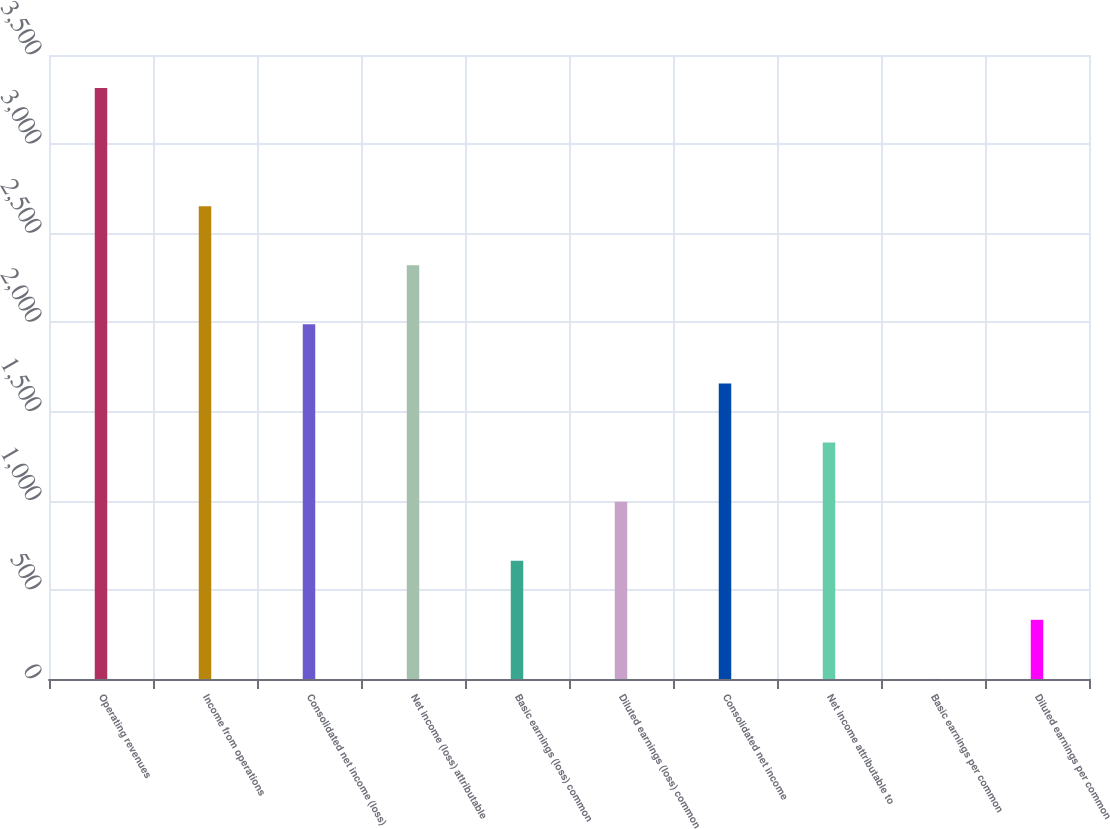Convert chart. <chart><loc_0><loc_0><loc_500><loc_500><bar_chart><fcel>Operating revenues<fcel>Income from operations<fcel>Consolidated net income (loss)<fcel>Net income (loss) attributable<fcel>Basic earnings (loss) common<fcel>Diluted earnings (loss) common<fcel>Consolidated net income<fcel>Net income attributable to<fcel>Basic earnings per common<fcel>Diluted earnings per common<nl><fcel>3315<fcel>2652.11<fcel>1989.2<fcel>2320.66<fcel>663.37<fcel>994.83<fcel>1657.74<fcel>1326.29<fcel>0.45<fcel>331.91<nl></chart> 